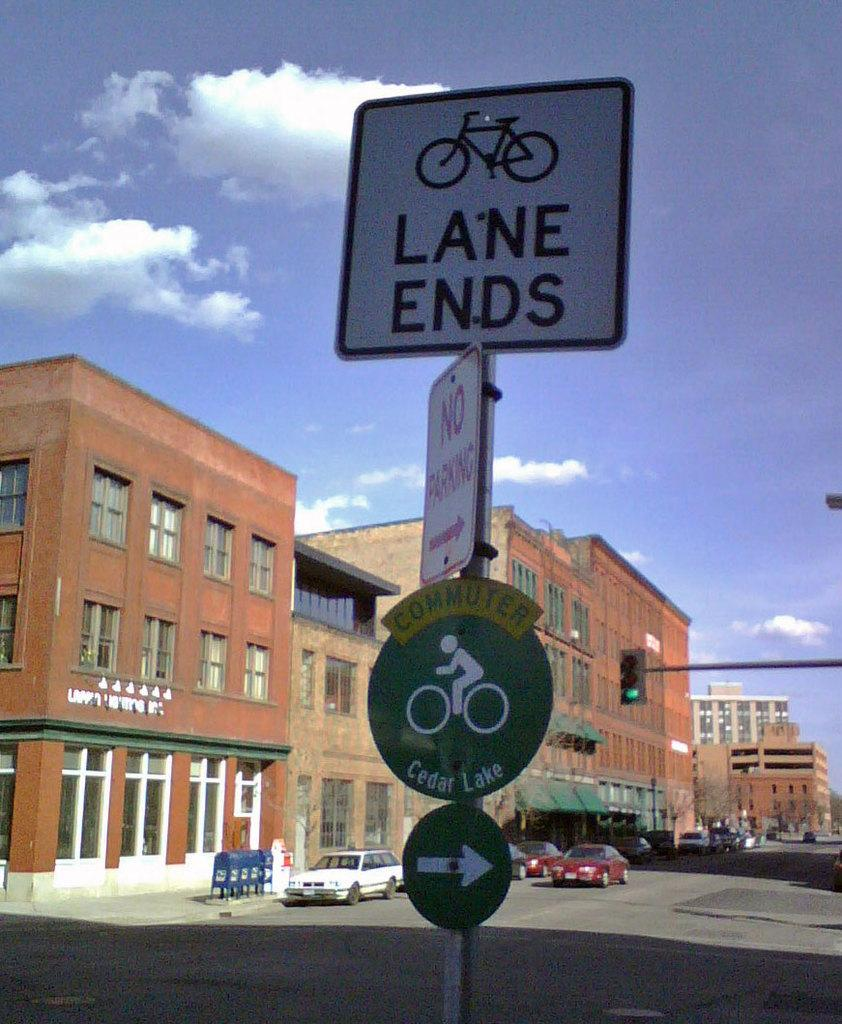<image>
Write a terse but informative summary of the picture. Sign which says LANE ENDS in front of a building. 